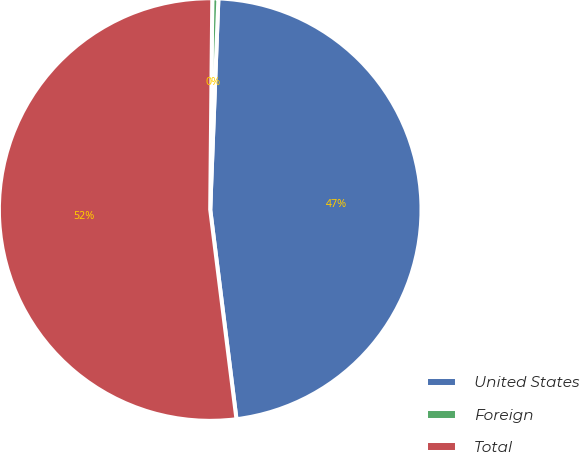Convert chart. <chart><loc_0><loc_0><loc_500><loc_500><pie_chart><fcel>United States<fcel>Foreign<fcel>Total<nl><fcel>47.4%<fcel>0.46%<fcel>52.14%<nl></chart> 